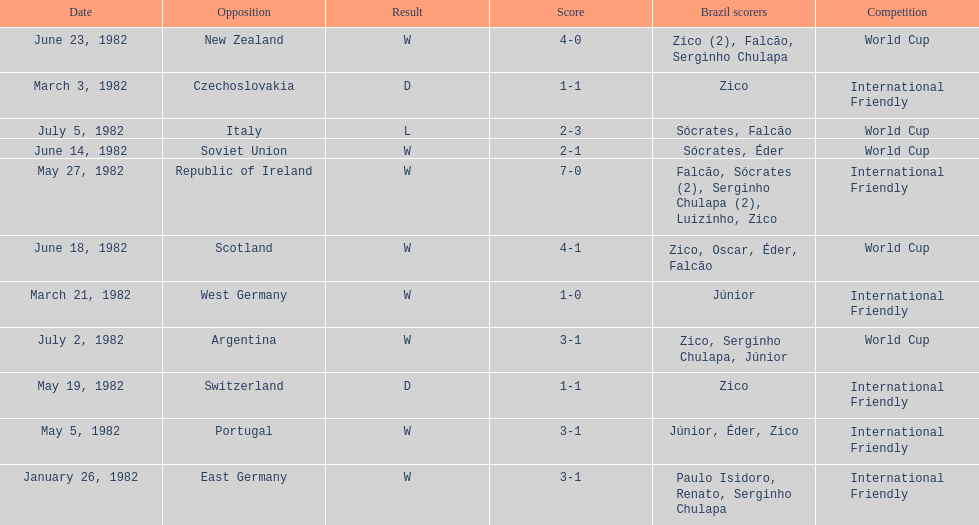What date is at the top of the list? January 26, 1982. 